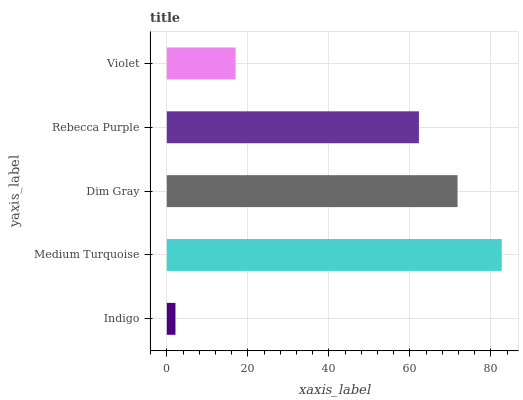Is Indigo the minimum?
Answer yes or no. Yes. Is Medium Turquoise the maximum?
Answer yes or no. Yes. Is Dim Gray the minimum?
Answer yes or no. No. Is Dim Gray the maximum?
Answer yes or no. No. Is Medium Turquoise greater than Dim Gray?
Answer yes or no. Yes. Is Dim Gray less than Medium Turquoise?
Answer yes or no. Yes. Is Dim Gray greater than Medium Turquoise?
Answer yes or no. No. Is Medium Turquoise less than Dim Gray?
Answer yes or no. No. Is Rebecca Purple the high median?
Answer yes or no. Yes. Is Rebecca Purple the low median?
Answer yes or no. Yes. Is Dim Gray the high median?
Answer yes or no. No. Is Violet the low median?
Answer yes or no. No. 